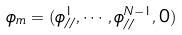<formula> <loc_0><loc_0><loc_500><loc_500>\phi _ { m } = ( \phi _ { / / } ^ { 1 } , \cdots , \phi _ { / / } ^ { N - 1 } , 0 )</formula> 